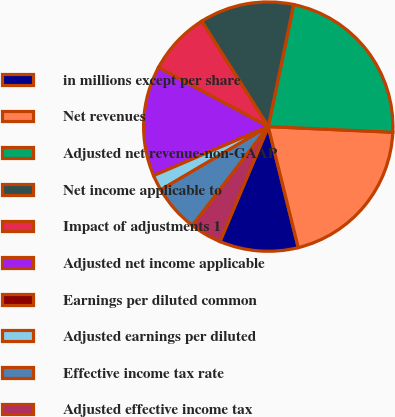<chart> <loc_0><loc_0><loc_500><loc_500><pie_chart><fcel>in millions except per share<fcel>Net revenues<fcel>Adjusted net revenue-non-GAAP<fcel>Net income applicable to<fcel>Impact of adjustments 1<fcel>Adjusted net income applicable<fcel>Earnings per diluted common<fcel>Adjusted earnings per diluted<fcel>Effective income tax rate<fcel>Adjusted effective income tax<nl><fcel>10.2%<fcel>20.41%<fcel>22.45%<fcel>12.24%<fcel>8.16%<fcel>14.29%<fcel>0.0%<fcel>2.04%<fcel>6.12%<fcel>4.08%<nl></chart> 